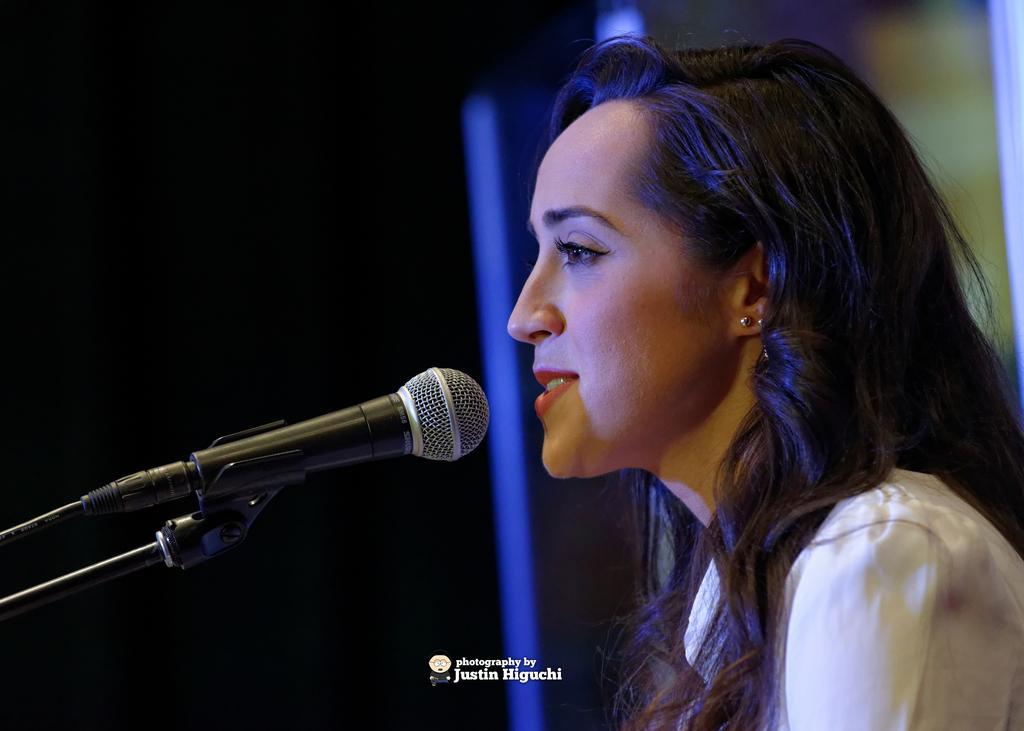Could you give a brief overview of what you see in this image? There is a woman, in front of her we can see microphone. In the background it is dark. At the bottom of the image we can see text. 